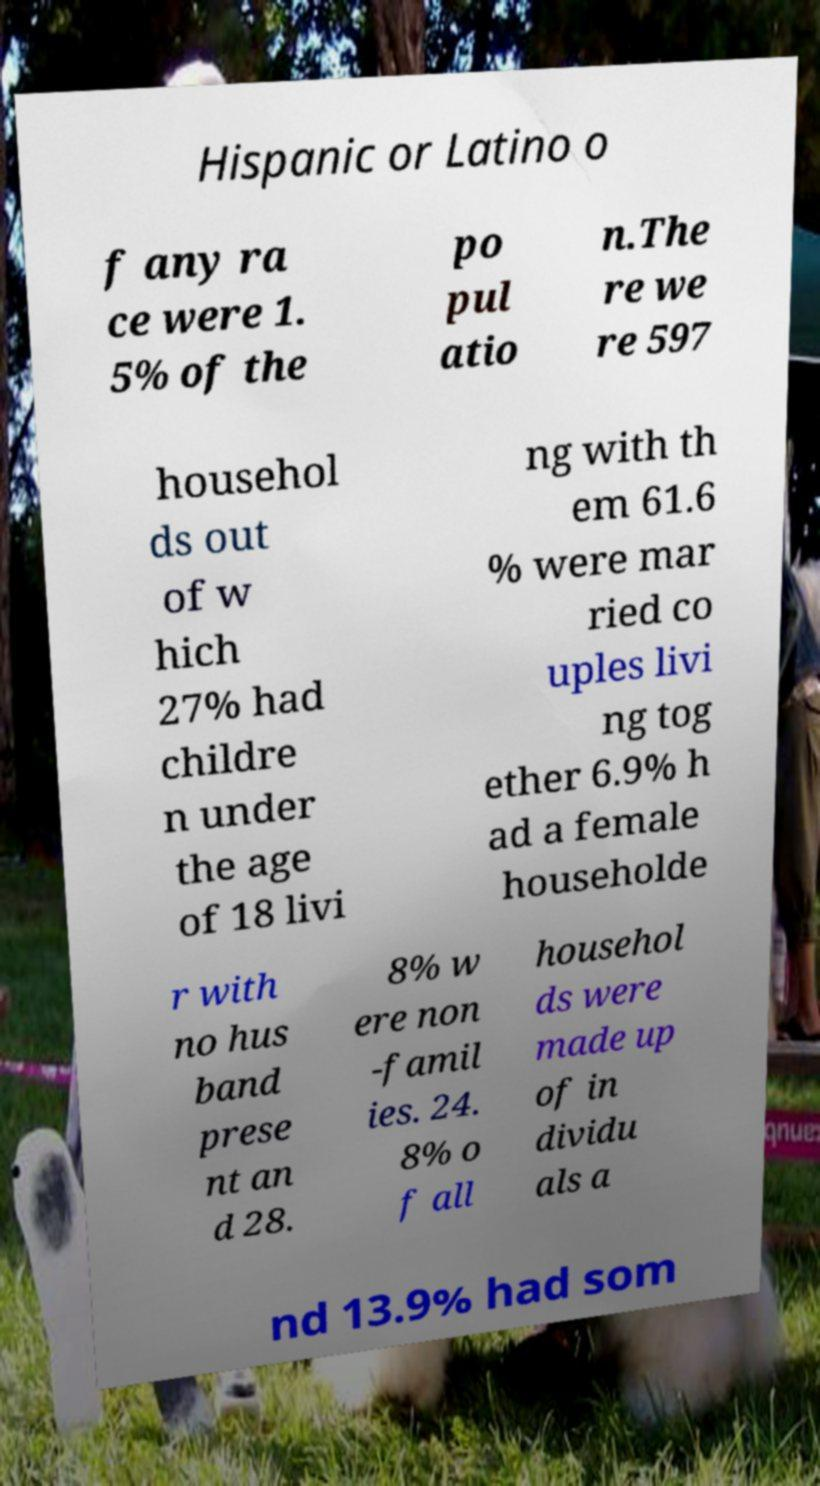For documentation purposes, I need the text within this image transcribed. Could you provide that? Hispanic or Latino o f any ra ce were 1. 5% of the po pul atio n.The re we re 597 househol ds out of w hich 27% had childre n under the age of 18 livi ng with th em 61.6 % were mar ried co uples livi ng tog ether 6.9% h ad a female householde r with no hus band prese nt an d 28. 8% w ere non -famil ies. 24. 8% o f all househol ds were made up of in dividu als a nd 13.9% had som 